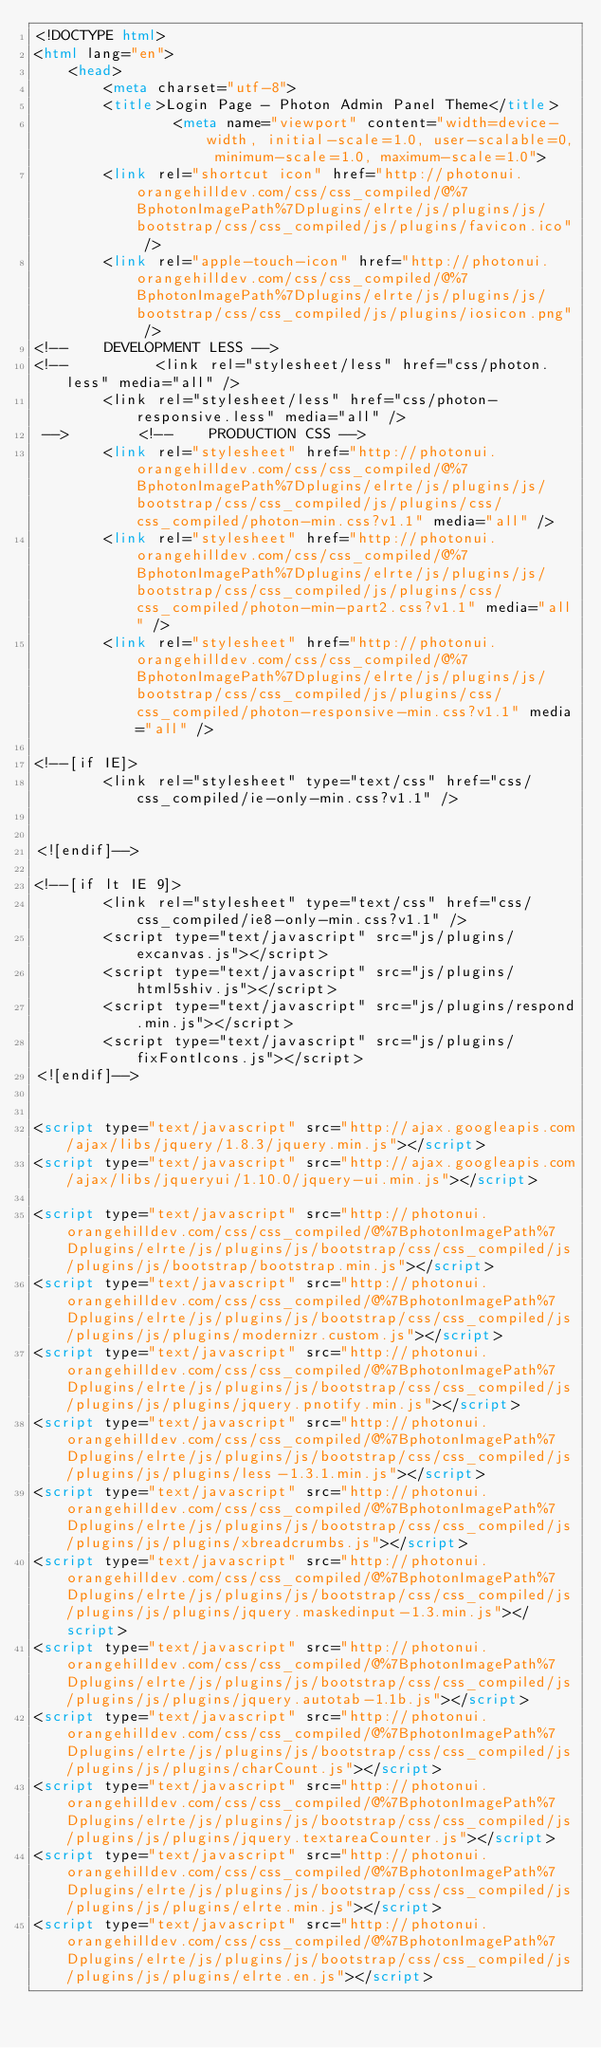<code> <loc_0><loc_0><loc_500><loc_500><_HTML_><!DOCTYPE html>
<html lang="en">
    <head>
        <meta charset="utf-8">
        <title>Login Page - Photon Admin Panel Theme</title>
                <meta name="viewport" content="width=device-width, initial-scale=1.0, user-scalable=0, minimum-scale=1.0, maximum-scale=1.0">
        <link rel="shortcut icon" href="http://photonui.orangehilldev.com/css/css_compiled/@%7BphotonImagePath%7Dplugins/elrte/js/plugins/js/bootstrap/css/css_compiled/js/plugins/favicon.ico" />
        <link rel="apple-touch-icon" href="http://photonui.orangehilldev.com/css/css_compiled/@%7BphotonImagePath%7Dplugins/elrte/js/plugins/js/bootstrap/css/css_compiled/js/plugins/iosicon.png" />
<!--    DEVELOPMENT LESS -->
<!--          <link rel="stylesheet/less" href="css/photon.less" media="all" />
        <link rel="stylesheet/less" href="css/photon-responsive.less" media="all" />
 -->        <!--    PRODUCTION CSS -->
        <link rel="stylesheet" href="http://photonui.orangehilldev.com/css/css_compiled/@%7BphotonImagePath%7Dplugins/elrte/js/plugins/js/bootstrap/css/css_compiled/js/plugins/css/css_compiled/photon-min.css?v1.1" media="all" />
        <link rel="stylesheet" href="http://photonui.orangehilldev.com/css/css_compiled/@%7BphotonImagePath%7Dplugins/elrte/js/plugins/js/bootstrap/css/css_compiled/js/plugins/css/css_compiled/photon-min-part2.css?v1.1" media="all" />
        <link rel="stylesheet" href="http://photonui.orangehilldev.com/css/css_compiled/@%7BphotonImagePath%7Dplugins/elrte/js/plugins/js/bootstrap/css/css_compiled/js/plugins/css/css_compiled/photon-responsive-min.css?v1.1" media="all" />

<!--[if IE]>
        <link rel="stylesheet" type="text/css" href="css/css_compiled/ie-only-min.css?v1.1" />
        

<![endif]-->

<!--[if lt IE 9]>
        <link rel="stylesheet" type="text/css" href="css/css_compiled/ie8-only-min.css?v1.1" />
        <script type="text/javascript" src="js/plugins/excanvas.js"></script>
        <script type="text/javascript" src="js/plugins/html5shiv.js"></script>
        <script type="text/javascript" src="js/plugins/respond.min.js"></script>
        <script type="text/javascript" src="js/plugins/fixFontIcons.js"></script>
<![endif]-->

        
<script type="text/javascript" src="http://ajax.googleapis.com/ajax/libs/jquery/1.8.3/jquery.min.js"></script>
<script type="text/javascript" src="http://ajax.googleapis.com/ajax/libs/jqueryui/1.10.0/jquery-ui.min.js"></script>

<script type="text/javascript" src="http://photonui.orangehilldev.com/css/css_compiled/@%7BphotonImagePath%7Dplugins/elrte/js/plugins/js/bootstrap/css/css_compiled/js/plugins/js/bootstrap/bootstrap.min.js"></script>
<script type="text/javascript" src="http://photonui.orangehilldev.com/css/css_compiled/@%7BphotonImagePath%7Dplugins/elrte/js/plugins/js/bootstrap/css/css_compiled/js/plugins/js/plugins/modernizr.custom.js"></script>
<script type="text/javascript" src="http://photonui.orangehilldev.com/css/css_compiled/@%7BphotonImagePath%7Dplugins/elrte/js/plugins/js/bootstrap/css/css_compiled/js/plugins/js/plugins/jquery.pnotify.min.js"></script>
<script type="text/javascript" src="http://photonui.orangehilldev.com/css/css_compiled/@%7BphotonImagePath%7Dplugins/elrte/js/plugins/js/bootstrap/css/css_compiled/js/plugins/js/plugins/less-1.3.1.min.js"></script>        
<script type="text/javascript" src="http://photonui.orangehilldev.com/css/css_compiled/@%7BphotonImagePath%7Dplugins/elrte/js/plugins/js/bootstrap/css/css_compiled/js/plugins/js/plugins/xbreadcrumbs.js"></script>
<script type="text/javascript" src="http://photonui.orangehilldev.com/css/css_compiled/@%7BphotonImagePath%7Dplugins/elrte/js/plugins/js/bootstrap/css/css_compiled/js/plugins/js/plugins/jquery.maskedinput-1.3.min.js"></script>
<script type="text/javascript" src="http://photonui.orangehilldev.com/css/css_compiled/@%7BphotonImagePath%7Dplugins/elrte/js/plugins/js/bootstrap/css/css_compiled/js/plugins/js/plugins/jquery.autotab-1.1b.js"></script>
<script type="text/javascript" src="http://photonui.orangehilldev.com/css/css_compiled/@%7BphotonImagePath%7Dplugins/elrte/js/plugins/js/bootstrap/css/css_compiled/js/plugins/js/plugins/charCount.js"></script>
<script type="text/javascript" src="http://photonui.orangehilldev.com/css/css_compiled/@%7BphotonImagePath%7Dplugins/elrte/js/plugins/js/bootstrap/css/css_compiled/js/plugins/js/plugins/jquery.textareaCounter.js"></script>
<script type="text/javascript" src="http://photonui.orangehilldev.com/css/css_compiled/@%7BphotonImagePath%7Dplugins/elrte/js/plugins/js/bootstrap/css/css_compiled/js/plugins/js/plugins/elrte.min.js"></script>
<script type="text/javascript" src="http://photonui.orangehilldev.com/css/css_compiled/@%7BphotonImagePath%7Dplugins/elrte/js/plugins/js/bootstrap/css/css_compiled/js/plugins/js/plugins/elrte.en.js"></script></code> 